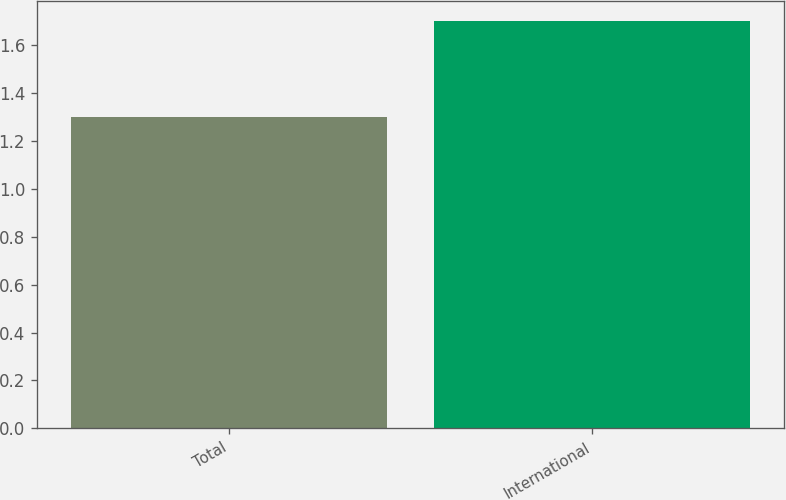Convert chart. <chart><loc_0><loc_0><loc_500><loc_500><bar_chart><fcel>Total<fcel>International<nl><fcel>1.3<fcel>1.7<nl></chart> 